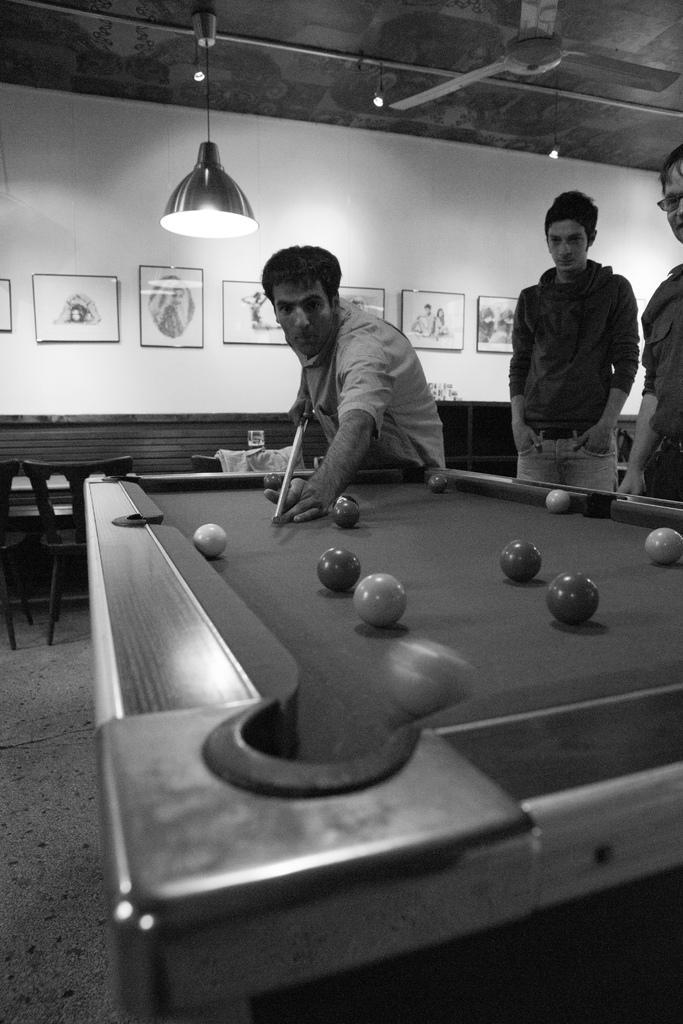Could you give a brief overview of what you see in this image? In this image on the right side there are two persons who are standing and in the middle there is one person who is standing and he is holding a stick, in front of him there is a one table and on the table there are some balls. And on the top there is ceiling and one fan and light is there on the ceiling and in the middle there is wall and on the wall there are some photo frames. 